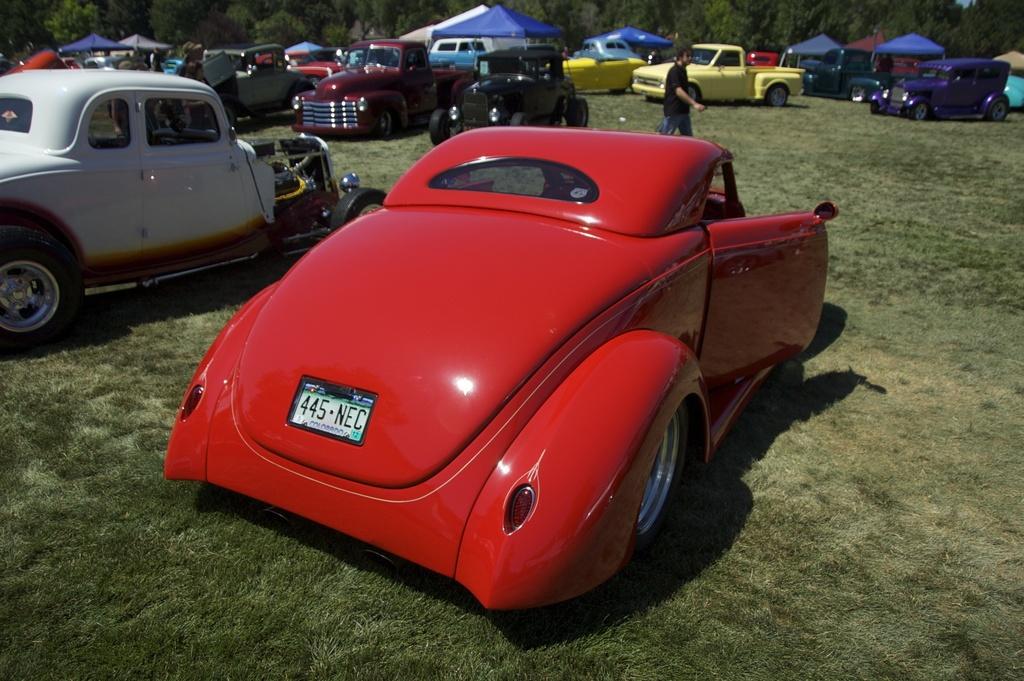Please provide a concise description of this image. In this image we can see vehicles. In the background of the image there are some vehicles, stalls, a person, trees and other objects. At bottom of the image there is the grass. 